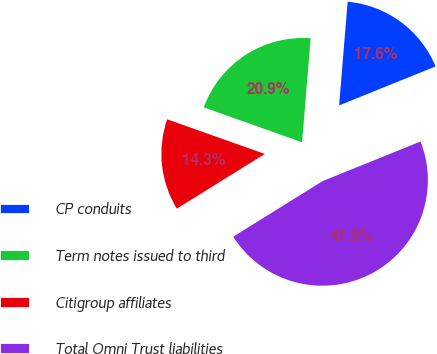Convert chart to OTSL. <chart><loc_0><loc_0><loc_500><loc_500><pie_chart><fcel>CP conduits<fcel>Term notes issued to third<fcel>Citigroup affiliates<fcel>Total Omni Trust liabilities<nl><fcel>17.58%<fcel>20.88%<fcel>14.28%<fcel>47.26%<nl></chart> 